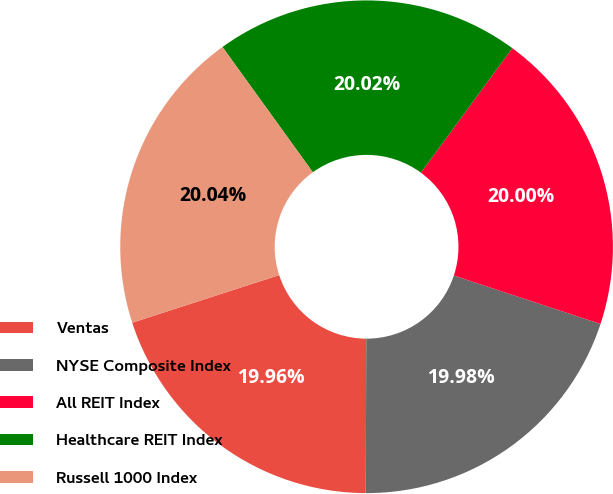<chart> <loc_0><loc_0><loc_500><loc_500><pie_chart><fcel>Ventas<fcel>NYSE Composite Index<fcel>All REIT Index<fcel>Healthcare REIT Index<fcel>Russell 1000 Index<nl><fcel>19.96%<fcel>19.98%<fcel>20.0%<fcel>20.02%<fcel>20.04%<nl></chart> 